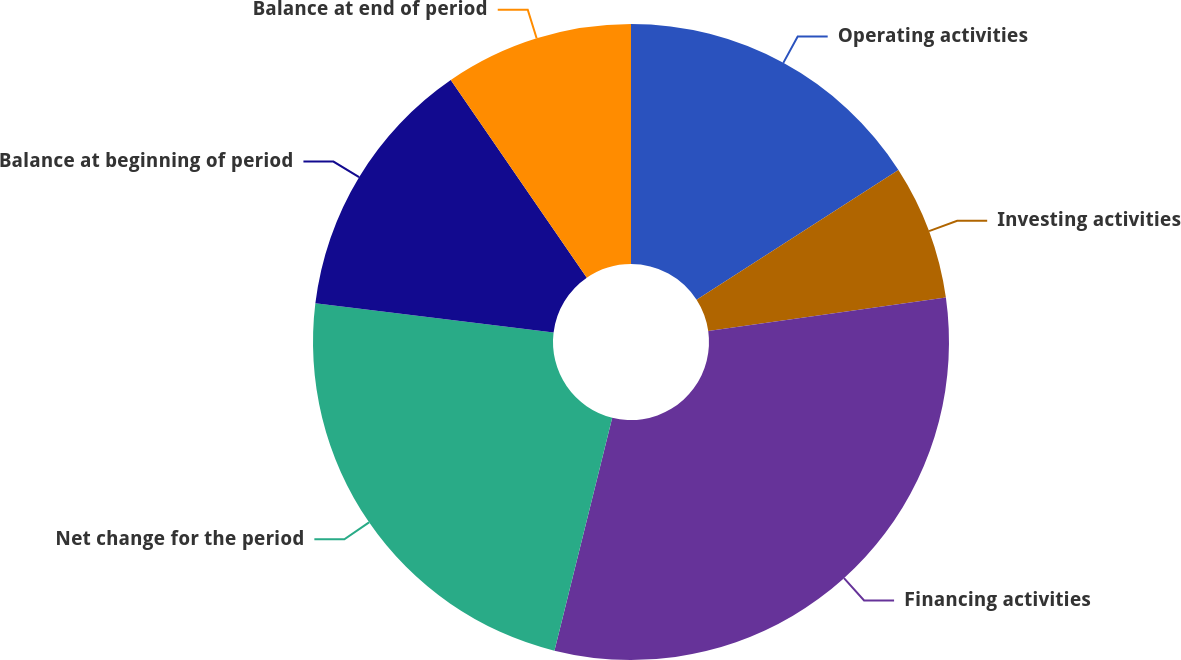Convert chart to OTSL. <chart><loc_0><loc_0><loc_500><loc_500><pie_chart><fcel>Operating activities<fcel>Investing activities<fcel>Financing activities<fcel>Net change for the period<fcel>Balance at beginning of period<fcel>Balance at end of period<nl><fcel>15.9%<fcel>6.87%<fcel>31.1%<fcel>23.07%<fcel>13.47%<fcel>9.59%<nl></chart> 